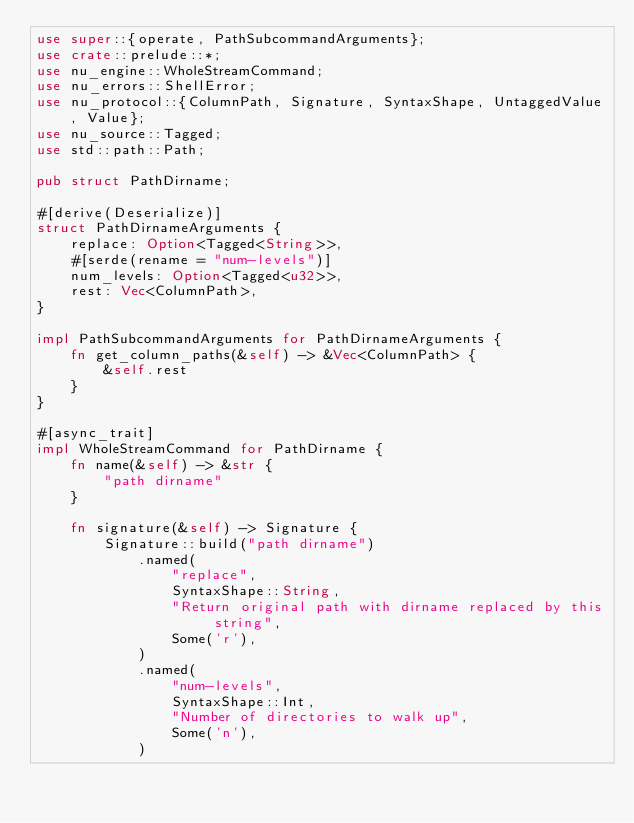<code> <loc_0><loc_0><loc_500><loc_500><_Rust_>use super::{operate, PathSubcommandArguments};
use crate::prelude::*;
use nu_engine::WholeStreamCommand;
use nu_errors::ShellError;
use nu_protocol::{ColumnPath, Signature, SyntaxShape, UntaggedValue, Value};
use nu_source::Tagged;
use std::path::Path;

pub struct PathDirname;

#[derive(Deserialize)]
struct PathDirnameArguments {
    replace: Option<Tagged<String>>,
    #[serde(rename = "num-levels")]
    num_levels: Option<Tagged<u32>>,
    rest: Vec<ColumnPath>,
}

impl PathSubcommandArguments for PathDirnameArguments {
    fn get_column_paths(&self) -> &Vec<ColumnPath> {
        &self.rest
    }
}

#[async_trait]
impl WholeStreamCommand for PathDirname {
    fn name(&self) -> &str {
        "path dirname"
    }

    fn signature(&self) -> Signature {
        Signature::build("path dirname")
            .named(
                "replace",
                SyntaxShape::String,
                "Return original path with dirname replaced by this string",
                Some('r'),
            )
            .named(
                "num-levels",
                SyntaxShape::Int,
                "Number of directories to walk up",
                Some('n'),
            )</code> 